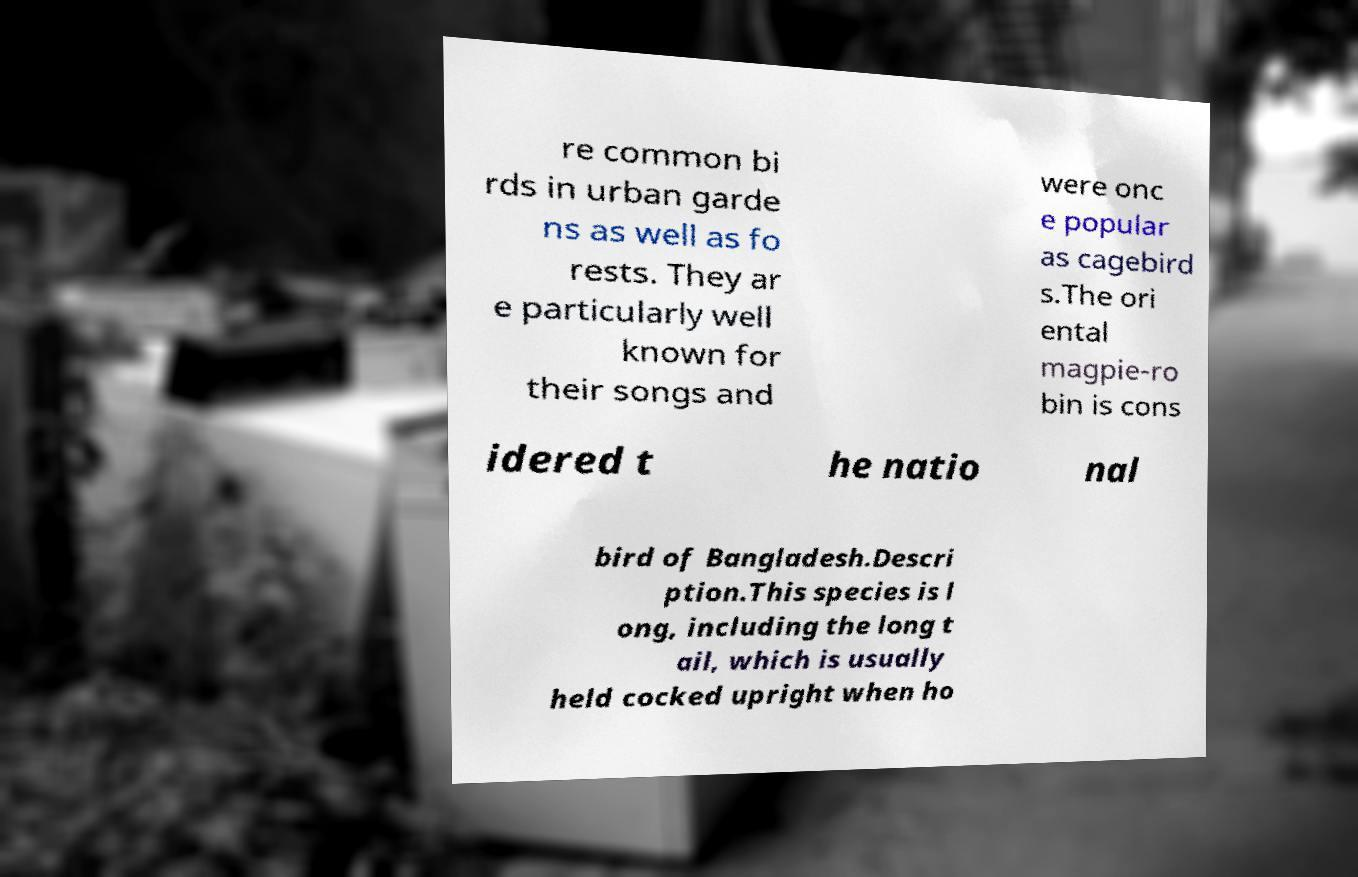I need the written content from this picture converted into text. Can you do that? re common bi rds in urban garde ns as well as fo rests. They ar e particularly well known for their songs and were onc e popular as cagebird s.The ori ental magpie-ro bin is cons idered t he natio nal bird of Bangladesh.Descri ption.This species is l ong, including the long t ail, which is usually held cocked upright when ho 